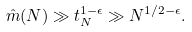<formula> <loc_0><loc_0><loc_500><loc_500>\hat { m } ( N ) \gg t _ { N } ^ { 1 - \epsilon } \gg N ^ { 1 / 2 - \epsilon } .</formula> 